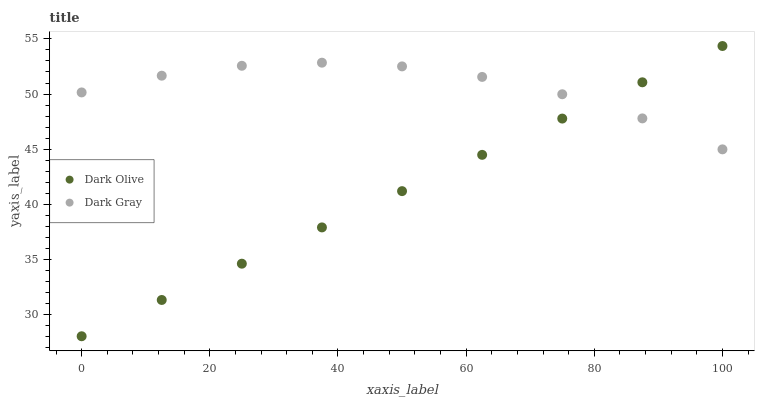Does Dark Olive have the minimum area under the curve?
Answer yes or no. Yes. Does Dark Gray have the maximum area under the curve?
Answer yes or no. Yes. Does Dark Olive have the maximum area under the curve?
Answer yes or no. No. Is Dark Olive the smoothest?
Answer yes or no. Yes. Is Dark Gray the roughest?
Answer yes or no. Yes. Is Dark Olive the roughest?
Answer yes or no. No. Does Dark Olive have the lowest value?
Answer yes or no. Yes. Does Dark Olive have the highest value?
Answer yes or no. Yes. Does Dark Olive intersect Dark Gray?
Answer yes or no. Yes. Is Dark Olive less than Dark Gray?
Answer yes or no. No. Is Dark Olive greater than Dark Gray?
Answer yes or no. No. 